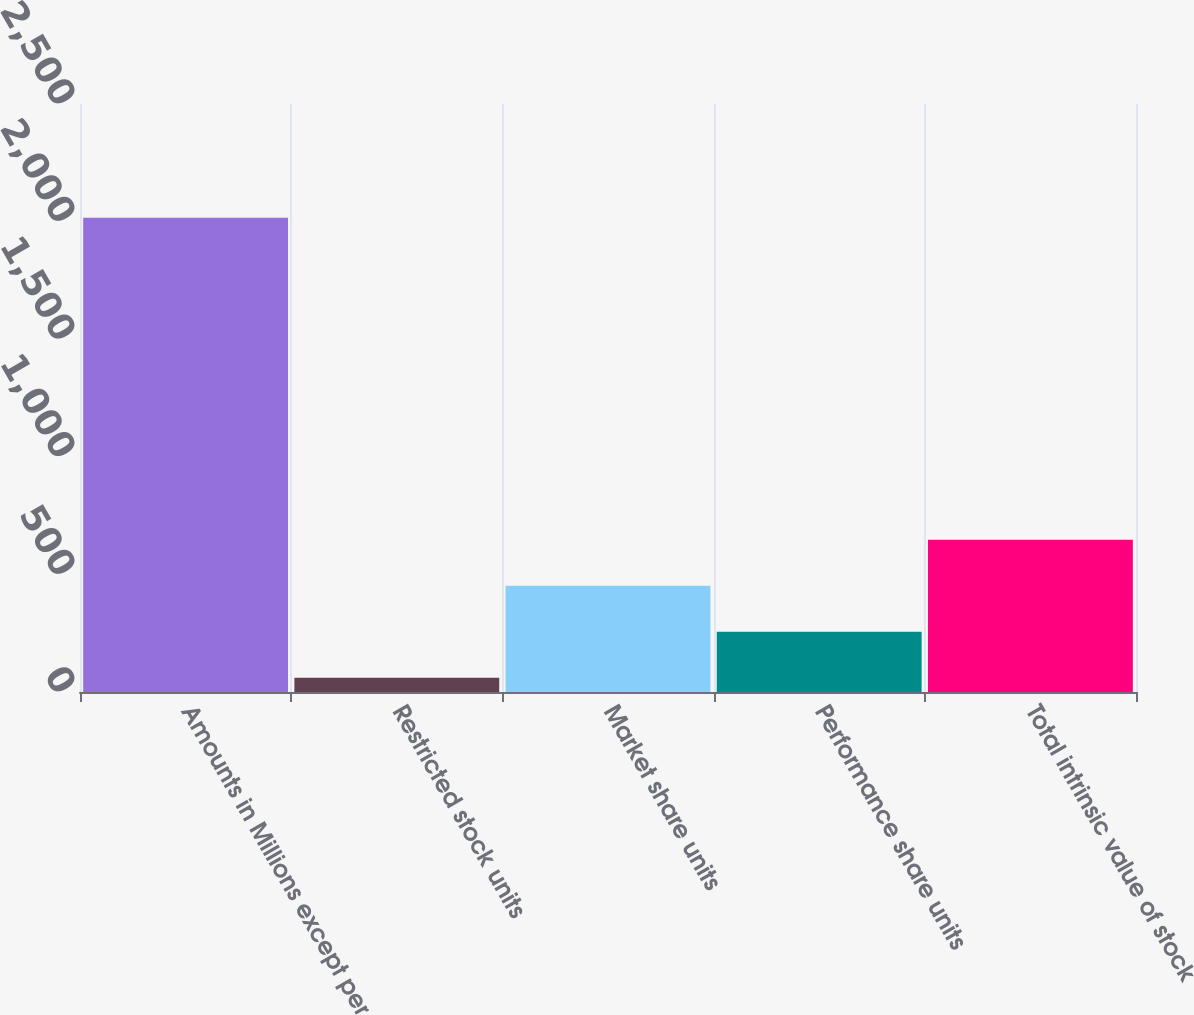Convert chart. <chart><loc_0><loc_0><loc_500><loc_500><bar_chart><fcel>Amounts in Millions except per<fcel>Restricted stock units<fcel>Market share units<fcel>Performance share units<fcel>Total intrinsic value of stock<nl><fcel>2016<fcel>60.56<fcel>451.64<fcel>256.1<fcel>647.18<nl></chart> 